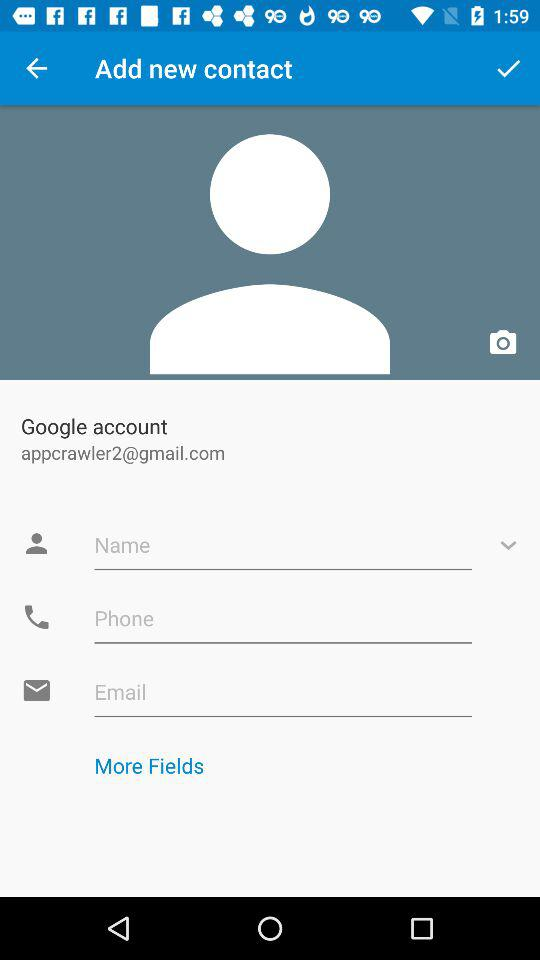What is the email address? The email address is appcrawler2@gmail.com. 